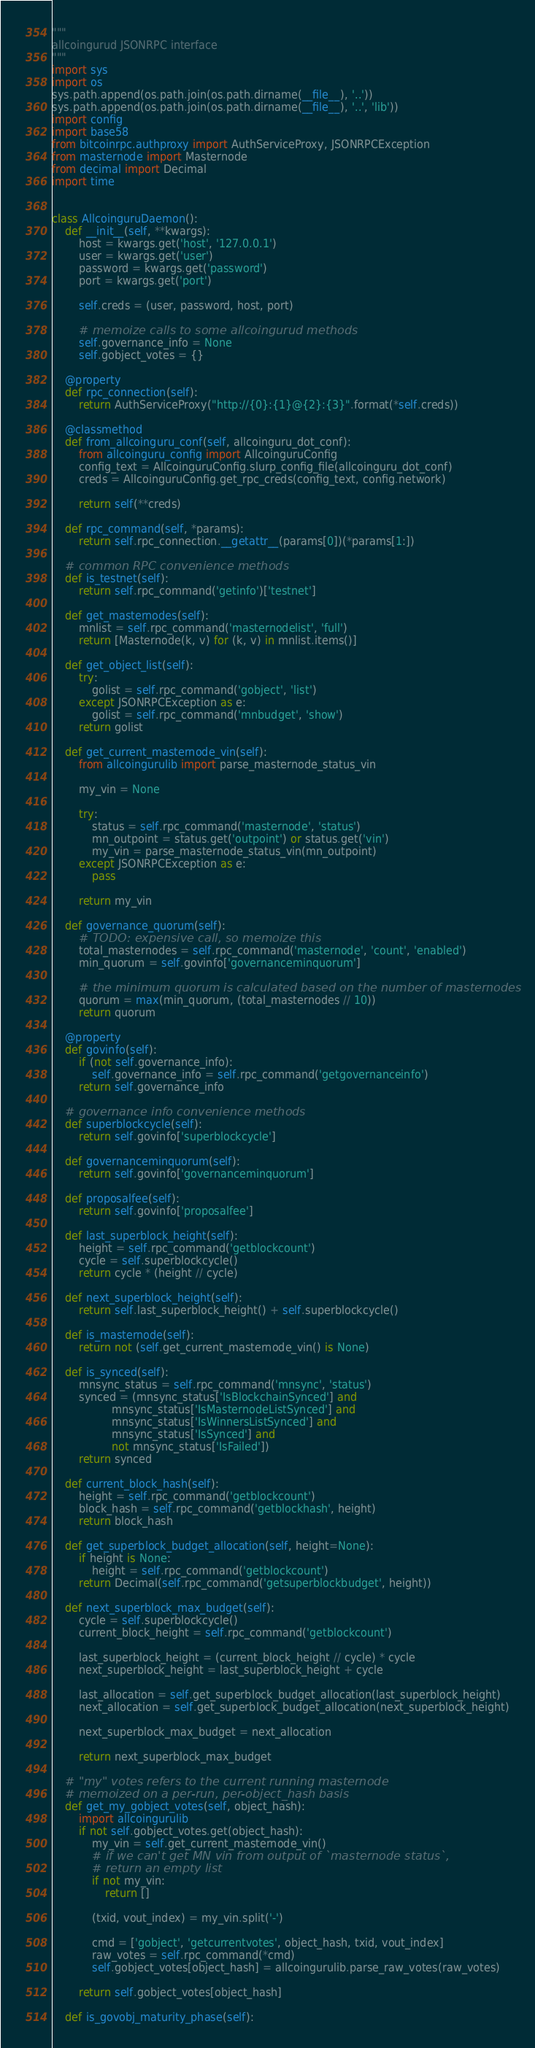Convert code to text. <code><loc_0><loc_0><loc_500><loc_500><_Python_>"""
allcoingurud JSONRPC interface
"""
import sys
import os
sys.path.append(os.path.join(os.path.dirname(__file__), '..'))
sys.path.append(os.path.join(os.path.dirname(__file__), '..', 'lib'))
import config
import base58
from bitcoinrpc.authproxy import AuthServiceProxy, JSONRPCException
from masternode import Masternode
from decimal import Decimal
import time


class AllcoinguruDaemon():
    def __init__(self, **kwargs):
        host = kwargs.get('host', '127.0.0.1')
        user = kwargs.get('user')
        password = kwargs.get('password')
        port = kwargs.get('port')

        self.creds = (user, password, host, port)

        # memoize calls to some allcoingurud methods
        self.governance_info = None
        self.gobject_votes = {}

    @property
    def rpc_connection(self):
        return AuthServiceProxy("http://{0}:{1}@{2}:{3}".format(*self.creds))

    @classmethod
    def from_allcoinguru_conf(self, allcoinguru_dot_conf):
        from allcoinguru_config import AllcoinguruConfig
        config_text = AllcoinguruConfig.slurp_config_file(allcoinguru_dot_conf)
        creds = AllcoinguruConfig.get_rpc_creds(config_text, config.network)

        return self(**creds)

    def rpc_command(self, *params):
        return self.rpc_connection.__getattr__(params[0])(*params[1:])

    # common RPC convenience methods
    def is_testnet(self):
        return self.rpc_command('getinfo')['testnet']

    def get_masternodes(self):
        mnlist = self.rpc_command('masternodelist', 'full')
        return [Masternode(k, v) for (k, v) in mnlist.items()]

    def get_object_list(self):
        try:
            golist = self.rpc_command('gobject', 'list')
        except JSONRPCException as e:
            golist = self.rpc_command('mnbudget', 'show')
        return golist

    def get_current_masternode_vin(self):
        from allcoingurulib import parse_masternode_status_vin

        my_vin = None

        try:
            status = self.rpc_command('masternode', 'status')
            mn_outpoint = status.get('outpoint') or status.get('vin')
            my_vin = parse_masternode_status_vin(mn_outpoint)
        except JSONRPCException as e:
            pass

        return my_vin

    def governance_quorum(self):
        # TODO: expensive call, so memoize this
        total_masternodes = self.rpc_command('masternode', 'count', 'enabled')
        min_quorum = self.govinfo['governanceminquorum']

        # the minimum quorum is calculated based on the number of masternodes
        quorum = max(min_quorum, (total_masternodes // 10))
        return quorum

    @property
    def govinfo(self):
        if (not self.governance_info):
            self.governance_info = self.rpc_command('getgovernanceinfo')
        return self.governance_info

    # governance info convenience methods
    def superblockcycle(self):
        return self.govinfo['superblockcycle']

    def governanceminquorum(self):
        return self.govinfo['governanceminquorum']

    def proposalfee(self):
        return self.govinfo['proposalfee']

    def last_superblock_height(self):
        height = self.rpc_command('getblockcount')
        cycle = self.superblockcycle()
        return cycle * (height // cycle)

    def next_superblock_height(self):
        return self.last_superblock_height() + self.superblockcycle()

    def is_masternode(self):
        return not (self.get_current_masternode_vin() is None)

    def is_synced(self):
        mnsync_status = self.rpc_command('mnsync', 'status')
        synced = (mnsync_status['IsBlockchainSynced'] and
                  mnsync_status['IsMasternodeListSynced'] and
                  mnsync_status['IsWinnersListSynced'] and
                  mnsync_status['IsSynced'] and
                  not mnsync_status['IsFailed'])
        return synced

    def current_block_hash(self):
        height = self.rpc_command('getblockcount')
        block_hash = self.rpc_command('getblockhash', height)
        return block_hash

    def get_superblock_budget_allocation(self, height=None):
        if height is None:
            height = self.rpc_command('getblockcount')
        return Decimal(self.rpc_command('getsuperblockbudget', height))

    def next_superblock_max_budget(self):
        cycle = self.superblockcycle()
        current_block_height = self.rpc_command('getblockcount')

        last_superblock_height = (current_block_height // cycle) * cycle
        next_superblock_height = last_superblock_height + cycle

        last_allocation = self.get_superblock_budget_allocation(last_superblock_height)
        next_allocation = self.get_superblock_budget_allocation(next_superblock_height)

        next_superblock_max_budget = next_allocation

        return next_superblock_max_budget

    # "my" votes refers to the current running masternode
    # memoized on a per-run, per-object_hash basis
    def get_my_gobject_votes(self, object_hash):
        import allcoingurulib
        if not self.gobject_votes.get(object_hash):
            my_vin = self.get_current_masternode_vin()
            # if we can't get MN vin from output of `masternode status`,
            # return an empty list
            if not my_vin:
                return []

            (txid, vout_index) = my_vin.split('-')

            cmd = ['gobject', 'getcurrentvotes', object_hash, txid, vout_index]
            raw_votes = self.rpc_command(*cmd)
            self.gobject_votes[object_hash] = allcoingurulib.parse_raw_votes(raw_votes)

        return self.gobject_votes[object_hash]

    def is_govobj_maturity_phase(self):</code> 